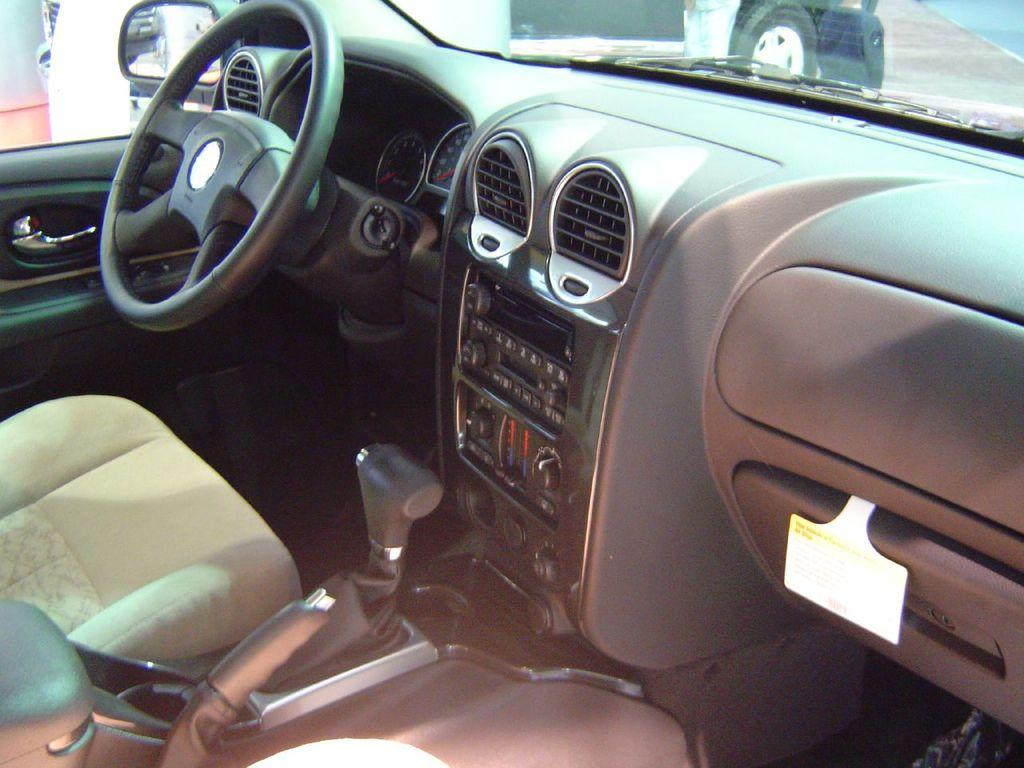What type of environment is depicted in the image? The image shows an internal view of a vehicle. What is the main control device in the vehicle? There is a steering wheel in the image. What is provided for the driver to sit on? There is a seat in the image. What is used for the driver to see behind them? There is a mirror in the image. How can the driver see the outside environment? There are windows in the image. What can be seen outside the vehicle through the windows? The image shows a road outside the vehicle. What type of sheet is covering the office in the image? There is no sheet or office present in the image; it shows an internal view of a vehicle. 